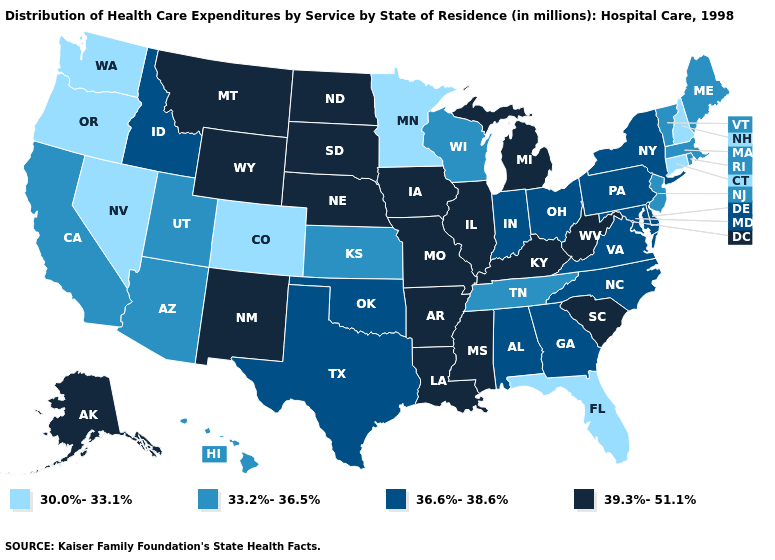Is the legend a continuous bar?
Short answer required. No. Does Iowa have a higher value than South Carolina?
Quick response, please. No. What is the lowest value in states that border Louisiana?
Short answer required. 36.6%-38.6%. Does North Carolina have the highest value in the South?
Be succinct. No. What is the value of Arkansas?
Keep it brief. 39.3%-51.1%. What is the highest value in states that border Arizona?
Short answer required. 39.3%-51.1%. Does Rhode Island have a higher value than Georgia?
Give a very brief answer. No. Which states have the lowest value in the USA?
Quick response, please. Colorado, Connecticut, Florida, Minnesota, Nevada, New Hampshire, Oregon, Washington. How many symbols are there in the legend?
Be succinct. 4. Does South Carolina have the lowest value in the USA?
Answer briefly. No. Among the states that border Kentucky , does Tennessee have the lowest value?
Concise answer only. Yes. Name the states that have a value in the range 33.2%-36.5%?
Quick response, please. Arizona, California, Hawaii, Kansas, Maine, Massachusetts, New Jersey, Rhode Island, Tennessee, Utah, Vermont, Wisconsin. What is the value of Montana?
Quick response, please. 39.3%-51.1%. Among the states that border North Dakota , does South Dakota have the highest value?
Write a very short answer. Yes. Name the states that have a value in the range 30.0%-33.1%?
Keep it brief. Colorado, Connecticut, Florida, Minnesota, Nevada, New Hampshire, Oregon, Washington. 